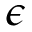Convert formula to latex. <formula><loc_0><loc_0><loc_500><loc_500>\epsilon</formula> 